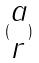<formula> <loc_0><loc_0><loc_500><loc_500>( \begin{matrix} a \\ r \end{matrix} )</formula> 